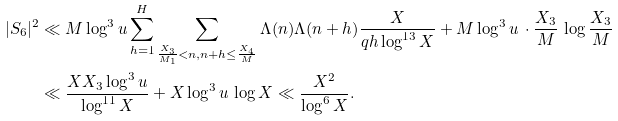Convert formula to latex. <formula><loc_0><loc_0><loc_500><loc_500>| S _ { 6 } | ^ { 2 } & \ll M \log ^ { 3 } u \sum _ { h = 1 } ^ { H } \sum _ { \frac { X _ { 3 } } { M _ { 1 } } < n , n + h \leq \frac { X _ { 4 } } { M } } \Lambda ( n ) \Lambda ( n + h ) \frac { X } { q h \log ^ { 1 3 } X } + M \log ^ { 3 } u \, \cdot \frac { X _ { 3 } } { M } \, \log \frac { X _ { 3 } } { M } \\ & \ll \frac { X X _ { 3 } \log ^ { 3 } u } { \log ^ { 1 1 } X } + X \log ^ { 3 } u \, \log X \ll \frac { X ^ { 2 } } { \log ^ { 6 } X } .</formula> 